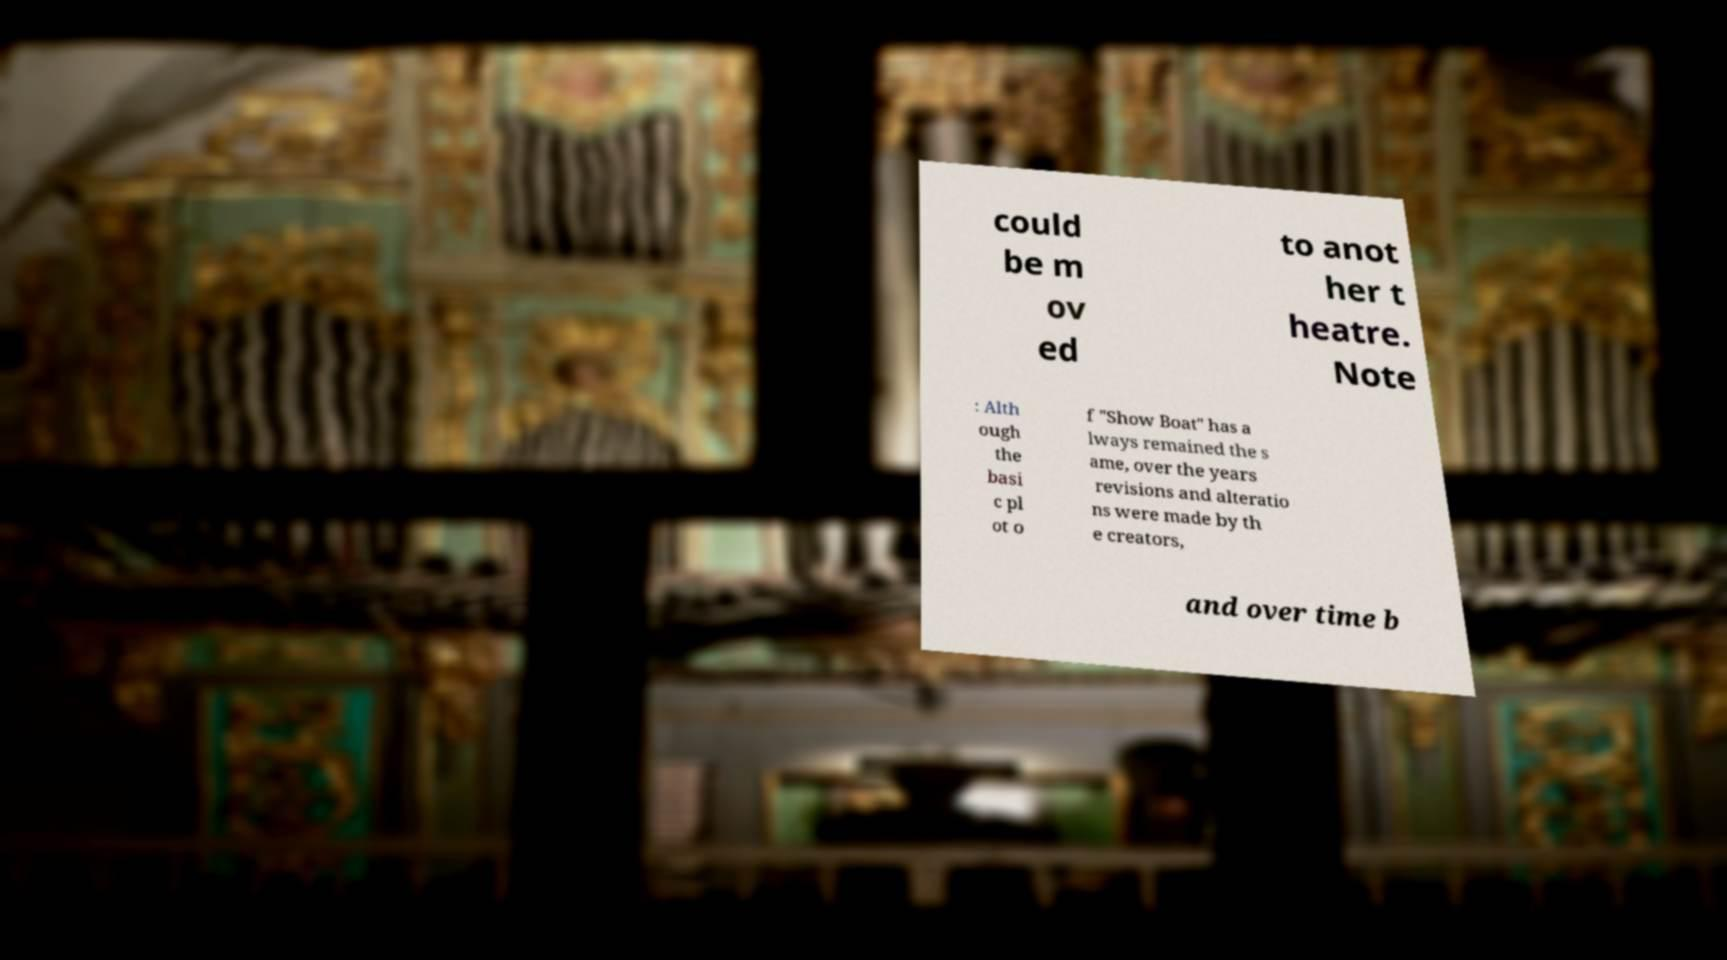Can you accurately transcribe the text from the provided image for me? could be m ov ed to anot her t heatre. Note : Alth ough the basi c pl ot o f "Show Boat" has a lways remained the s ame, over the years revisions and alteratio ns were made by th e creators, and over time b 